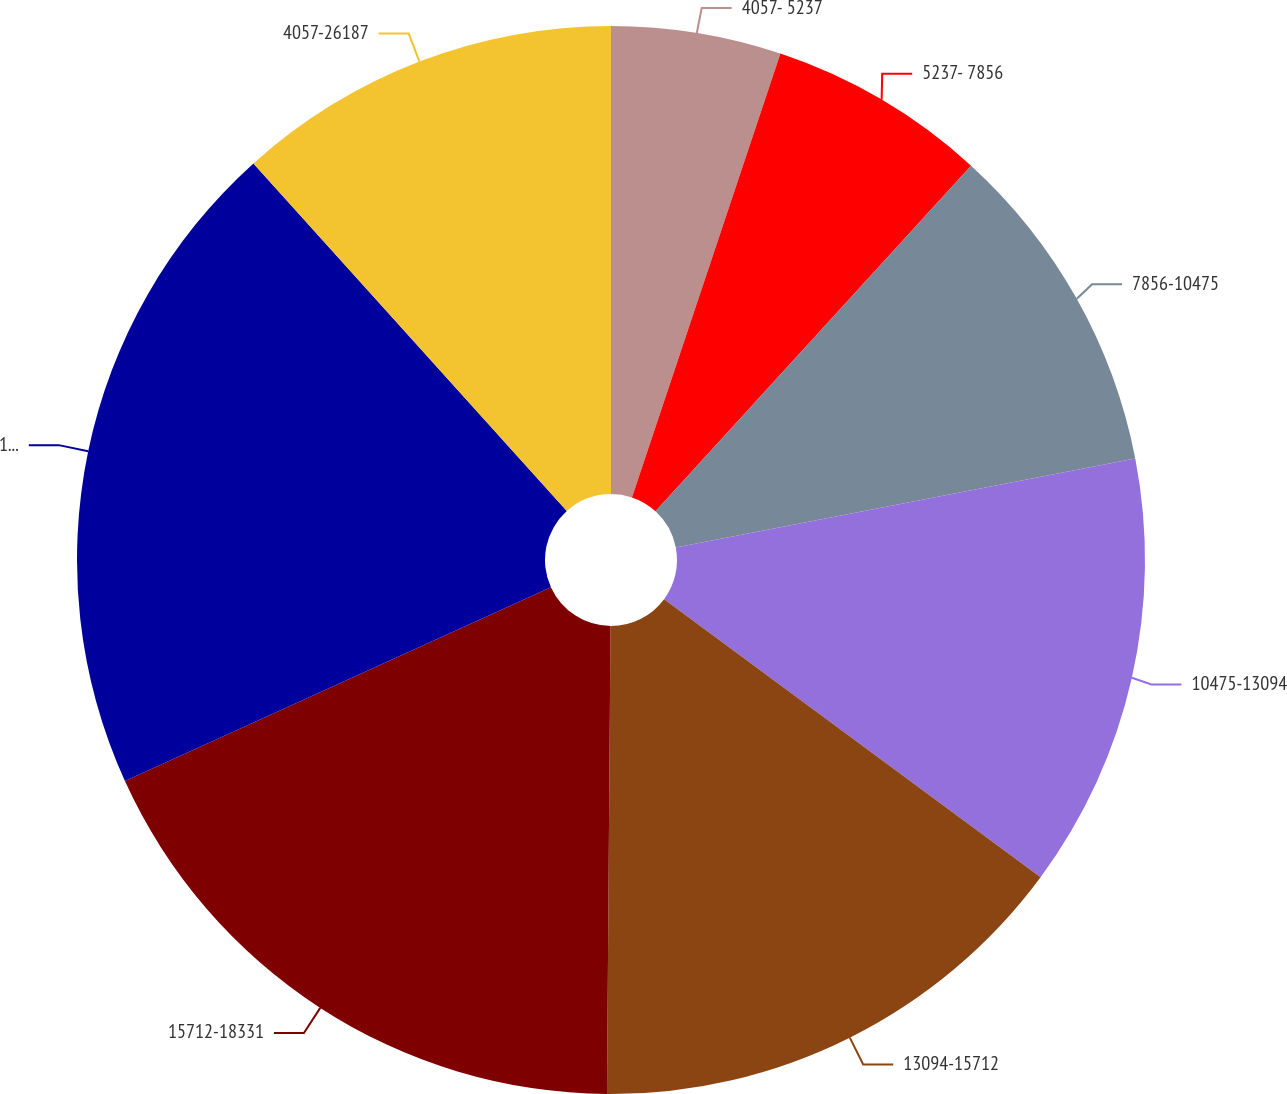<chart> <loc_0><loc_0><loc_500><loc_500><pie_chart><fcel>4057- 5237<fcel>5237- 7856<fcel>7856-10475<fcel>10475-13094<fcel>13094-15712<fcel>15712-18331<fcel>18331-20950<fcel>4057-26187<nl><fcel>5.14%<fcel>6.64%<fcel>10.18%<fcel>13.17%<fcel>15.0%<fcel>18.09%<fcel>20.12%<fcel>11.68%<nl></chart> 